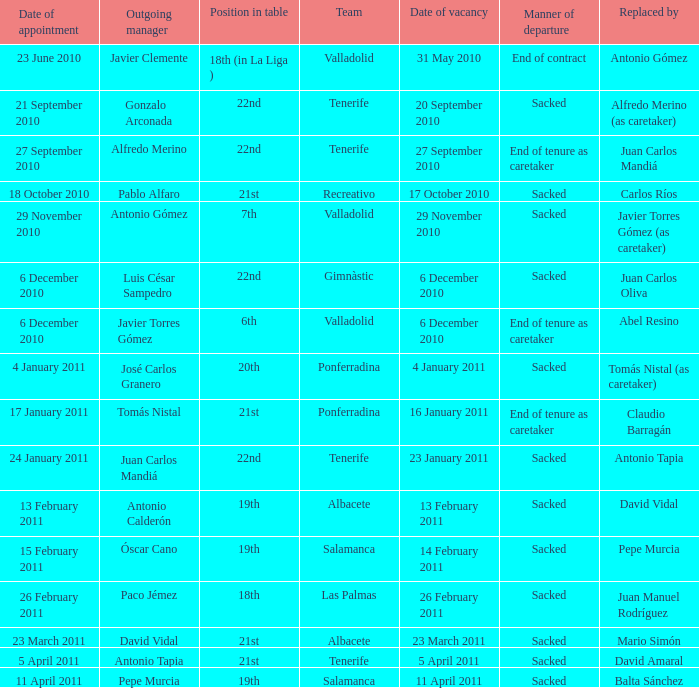How many teams had an appointment date of 11 april 2011 1.0. 